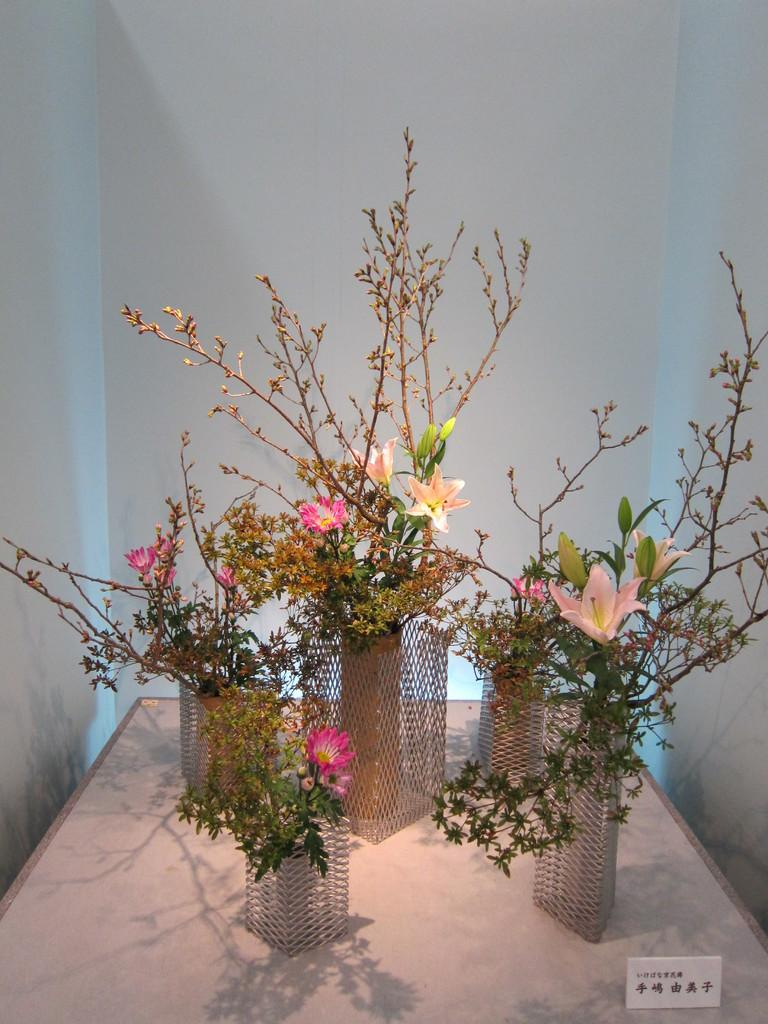What type of plants can be seen in the image? There are flowers in the image. How are the flowers arranged or displayed? The flowers are placed in flower vases. Where are the flower vases located? The flower vases are on a table. What can be seen in the background of the image? There is a wall in the background of the image. Can you tell me how many kittens are swimming in the waste in the image? There are no kittens or waste present in the image; it features flowers in flower vases on a table with a wall in the background. 